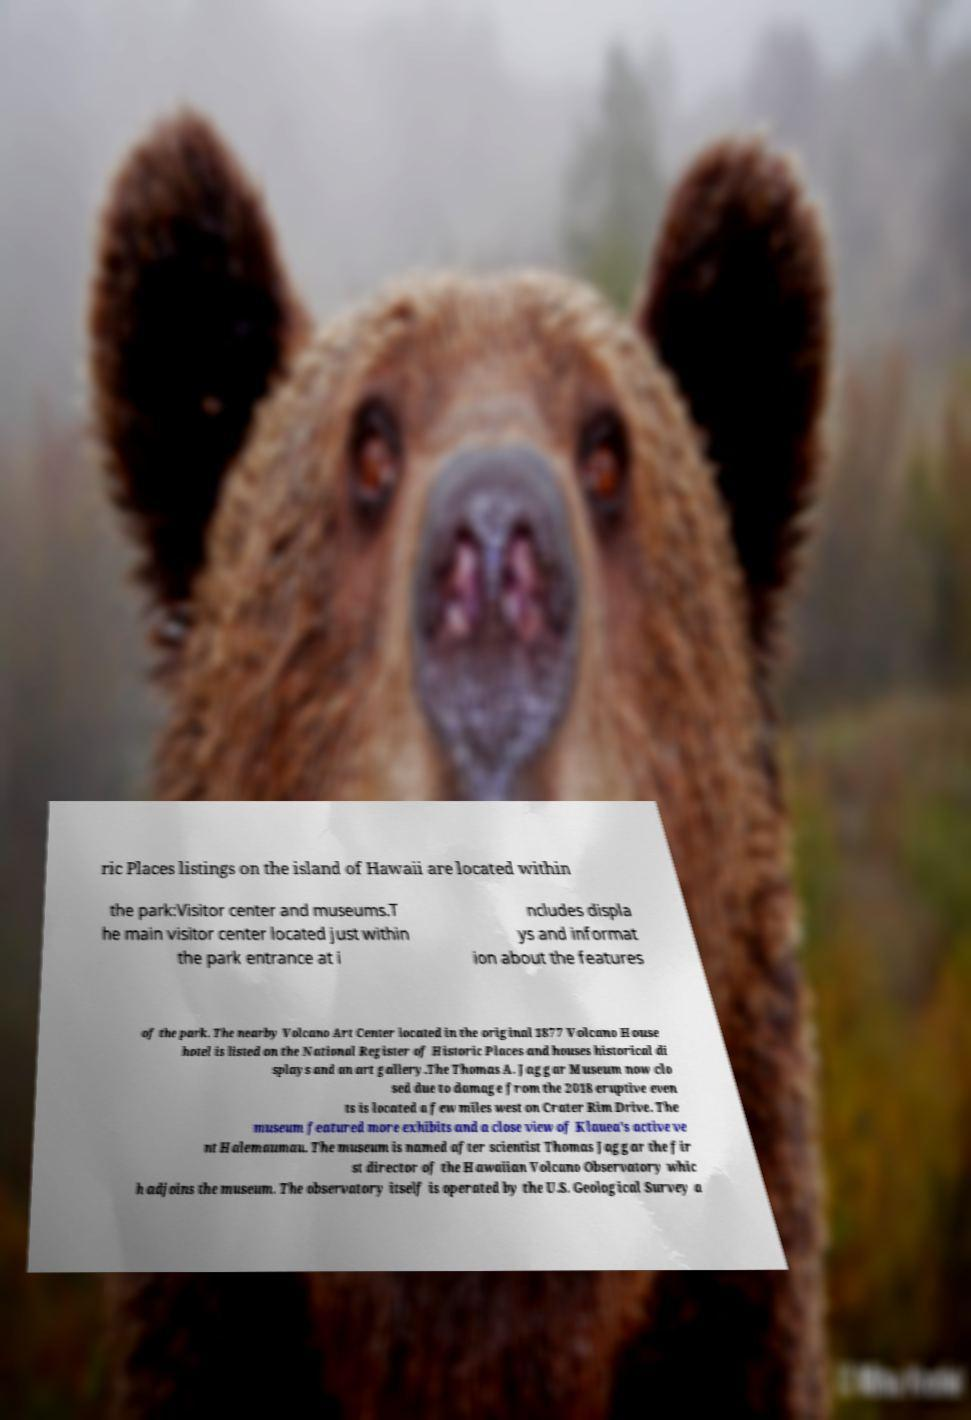Could you extract and type out the text from this image? ric Places listings on the island of Hawaii are located within the park:Visitor center and museums.T he main visitor center located just within the park entrance at i ncludes displa ys and informat ion about the features of the park. The nearby Volcano Art Center located in the original 1877 Volcano House hotel is listed on the National Register of Historic Places and houses historical di splays and an art gallery.The Thomas A. Jaggar Museum now clo sed due to damage from the 2018 eruptive even ts is located a few miles west on Crater Rim Drive. The museum featured more exhibits and a close view of Klauea's active ve nt Halemaumau. The museum is named after scientist Thomas Jaggar the fir st director of the Hawaiian Volcano Observatory whic h adjoins the museum. The observatory itself is operated by the U.S. Geological Survey a 